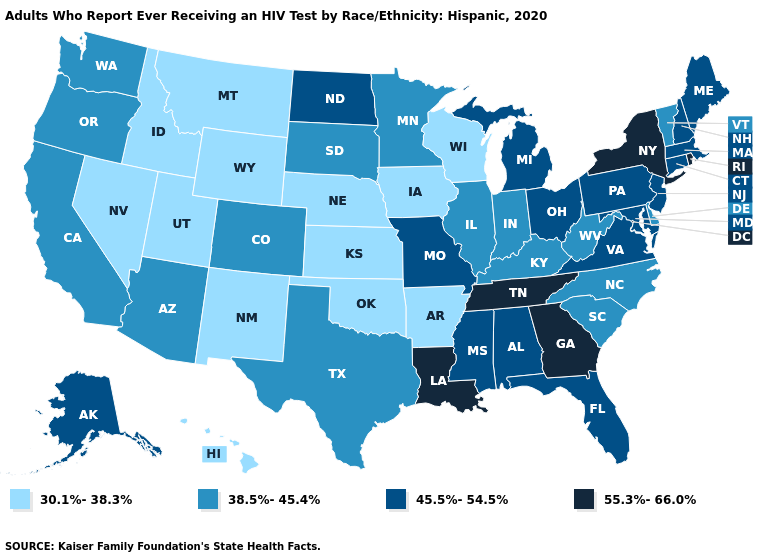What is the value of Louisiana?
Short answer required. 55.3%-66.0%. Does Washington have the lowest value in the West?
Be succinct. No. Does Alaska have the lowest value in the West?
Answer briefly. No. Does New Jersey have the highest value in the USA?
Concise answer only. No. What is the value of Arizona?
Write a very short answer. 38.5%-45.4%. Name the states that have a value in the range 38.5%-45.4%?
Keep it brief. Arizona, California, Colorado, Delaware, Illinois, Indiana, Kentucky, Minnesota, North Carolina, Oregon, South Carolina, South Dakota, Texas, Vermont, Washington, West Virginia. What is the lowest value in the USA?
Concise answer only. 30.1%-38.3%. Name the states that have a value in the range 38.5%-45.4%?
Answer briefly. Arizona, California, Colorado, Delaware, Illinois, Indiana, Kentucky, Minnesota, North Carolina, Oregon, South Carolina, South Dakota, Texas, Vermont, Washington, West Virginia. Which states have the highest value in the USA?
Keep it brief. Georgia, Louisiana, New York, Rhode Island, Tennessee. Does the map have missing data?
Be succinct. No. What is the value of Colorado?
Answer briefly. 38.5%-45.4%. Among the states that border Illinois , does Kentucky have the lowest value?
Write a very short answer. No. Name the states that have a value in the range 45.5%-54.5%?
Give a very brief answer. Alabama, Alaska, Connecticut, Florida, Maine, Maryland, Massachusetts, Michigan, Mississippi, Missouri, New Hampshire, New Jersey, North Dakota, Ohio, Pennsylvania, Virginia. How many symbols are there in the legend?
Write a very short answer. 4. Which states have the lowest value in the USA?
Give a very brief answer. Arkansas, Hawaii, Idaho, Iowa, Kansas, Montana, Nebraska, Nevada, New Mexico, Oklahoma, Utah, Wisconsin, Wyoming. 